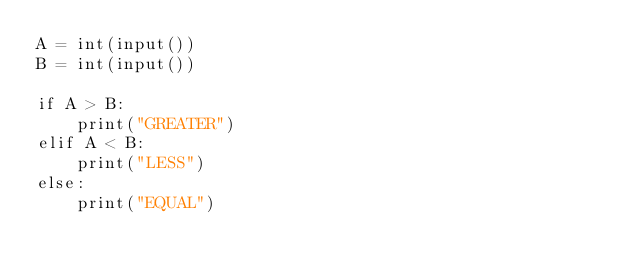<code> <loc_0><loc_0><loc_500><loc_500><_Python_>A = int(input())
B = int(input())

if A > B:
    print("GREATER")
elif A < B:
    print("LESS")
else:
    print("EQUAL")</code> 